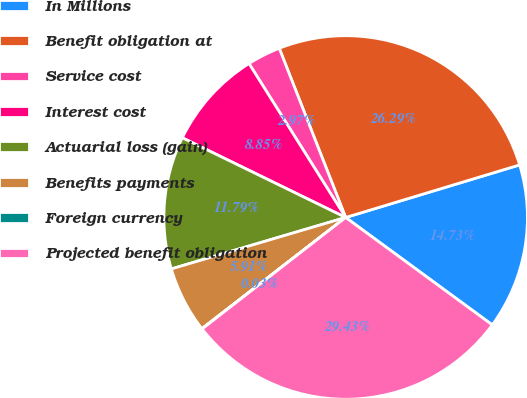<chart> <loc_0><loc_0><loc_500><loc_500><pie_chart><fcel>In Millions<fcel>Benefit obligation at<fcel>Service cost<fcel>Interest cost<fcel>Actuarial loss (gain)<fcel>Benefits payments<fcel>Foreign currency<fcel>Projected benefit obligation<nl><fcel>14.73%<fcel>26.28%<fcel>2.97%<fcel>8.85%<fcel>11.79%<fcel>5.91%<fcel>0.03%<fcel>29.42%<nl></chart> 